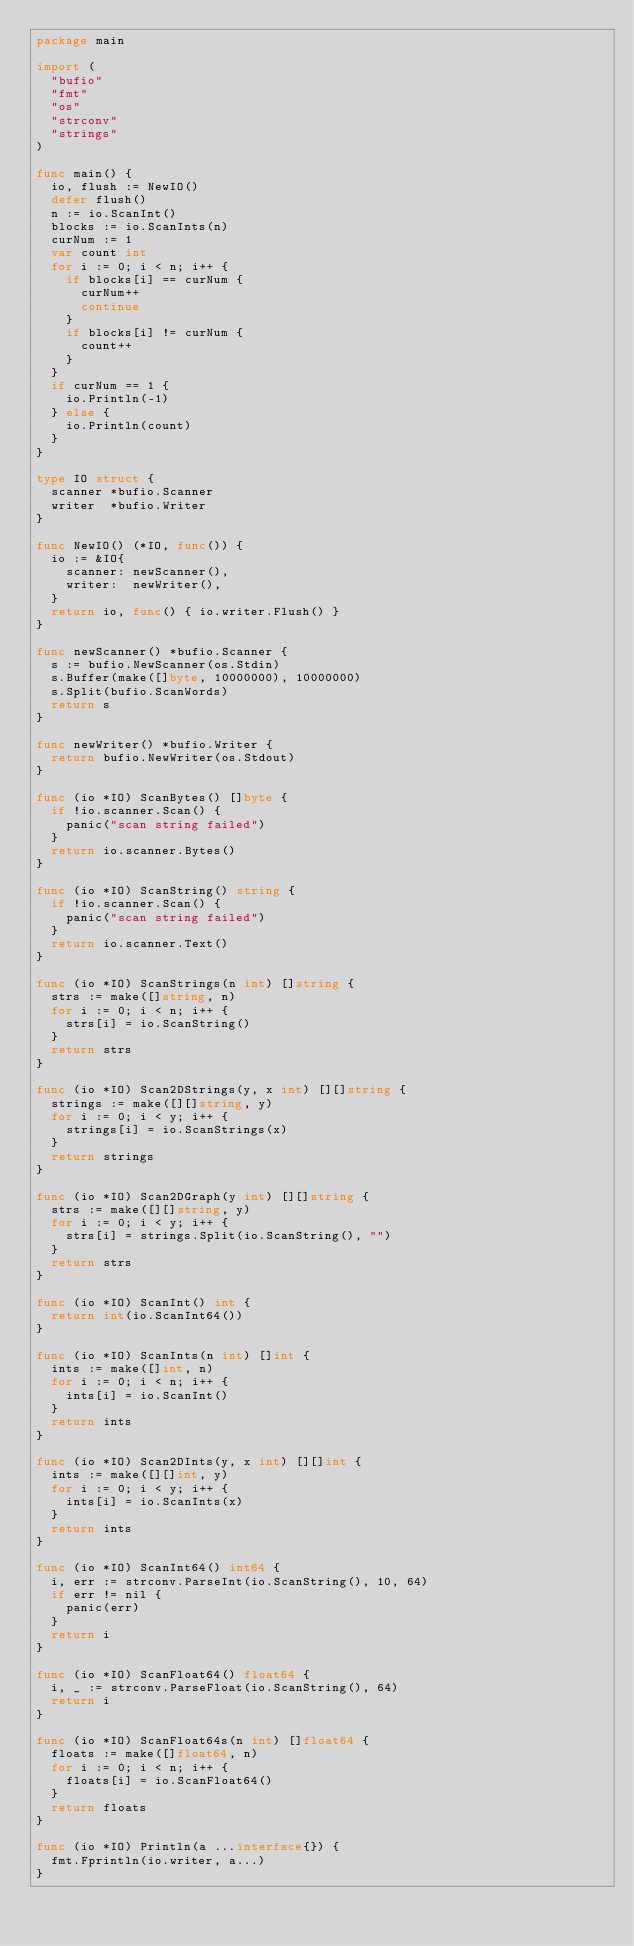Convert code to text. <code><loc_0><loc_0><loc_500><loc_500><_Go_>package main

import (
	"bufio"
	"fmt"
	"os"
	"strconv"
	"strings"
)

func main() {
	io, flush := NewIO()
	defer flush()
	n := io.ScanInt()
	blocks := io.ScanInts(n)
	curNum := 1
	var count int
	for i := 0; i < n; i++ {
		if blocks[i] == curNum {
			curNum++
			continue
		}
		if blocks[i] != curNum {
			count++
		}
	}
	if curNum == 1 {
		io.Println(-1)
	} else {
		io.Println(count)
	}
}

type IO struct {
	scanner *bufio.Scanner
	writer  *bufio.Writer
}

func NewIO() (*IO, func()) {
	io := &IO{
		scanner: newScanner(),
		writer:  newWriter(),
	}
	return io, func() { io.writer.Flush() }
}

func newScanner() *bufio.Scanner {
	s := bufio.NewScanner(os.Stdin)
	s.Buffer(make([]byte, 10000000), 10000000)
	s.Split(bufio.ScanWords)
	return s
}

func newWriter() *bufio.Writer {
	return bufio.NewWriter(os.Stdout)
}

func (io *IO) ScanBytes() []byte {
	if !io.scanner.Scan() {
		panic("scan string failed")
	}
	return io.scanner.Bytes()
}

func (io *IO) ScanString() string {
	if !io.scanner.Scan() {
		panic("scan string failed")
	}
	return io.scanner.Text()
}

func (io *IO) ScanStrings(n int) []string {
	strs := make([]string, n)
	for i := 0; i < n; i++ {
		strs[i] = io.ScanString()
	}
	return strs
}

func (io *IO) Scan2DStrings(y, x int) [][]string {
	strings := make([][]string, y)
	for i := 0; i < y; i++ {
		strings[i] = io.ScanStrings(x)
	}
	return strings
}

func (io *IO) Scan2DGraph(y int) [][]string {
	strs := make([][]string, y)
	for i := 0; i < y; i++ {
		strs[i] = strings.Split(io.ScanString(), "")
	}
	return strs
}

func (io *IO) ScanInt() int {
	return int(io.ScanInt64())
}

func (io *IO) ScanInts(n int) []int {
	ints := make([]int, n)
	for i := 0; i < n; i++ {
		ints[i] = io.ScanInt()
	}
	return ints
}

func (io *IO) Scan2DInts(y, x int) [][]int {
	ints := make([][]int, y)
	for i := 0; i < y; i++ {
		ints[i] = io.ScanInts(x)
	}
	return ints
}

func (io *IO) ScanInt64() int64 {
	i, err := strconv.ParseInt(io.ScanString(), 10, 64)
	if err != nil {
		panic(err)
	}
	return i
}

func (io *IO) ScanFloat64() float64 {
	i, _ := strconv.ParseFloat(io.ScanString(), 64)
	return i
}

func (io *IO) ScanFloat64s(n int) []float64 {
	floats := make([]float64, n)
	for i := 0; i < n; i++ {
		floats[i] = io.ScanFloat64()
	}
	return floats
}

func (io *IO) Println(a ...interface{}) {
	fmt.Fprintln(io.writer, a...)
}
</code> 